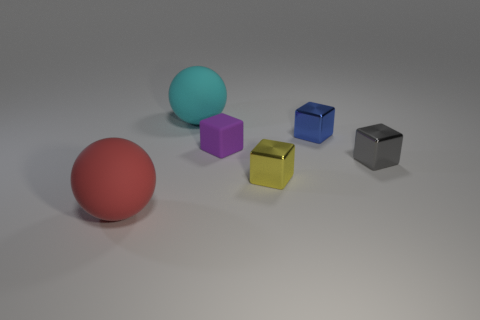Subtract all small blue metal cubes. How many cubes are left? 3 Add 2 small matte cubes. How many objects exist? 8 Subtract all gray blocks. How many blocks are left? 3 Subtract 2 cubes. How many cubes are left? 2 Subtract all cyan spheres. Subtract all yellow cylinders. How many spheres are left? 1 Subtract all brown cylinders. How many blue cubes are left? 1 Subtract all small objects. Subtract all tiny blue objects. How many objects are left? 1 Add 3 tiny yellow metal objects. How many tiny yellow metal objects are left? 4 Add 4 tiny blue metal blocks. How many tiny blue metal blocks exist? 5 Subtract 1 blue cubes. How many objects are left? 5 